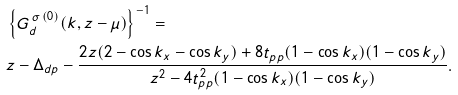Convert formula to latex. <formula><loc_0><loc_0><loc_500><loc_500>& \left \{ G _ { d } ^ { \, \sigma \, ( 0 ) } ( k , z - \mu ) \right \} ^ { - 1 } = \\ & z - \Delta _ { d p } - \frac { 2 z ( 2 - \cos k _ { x } - \cos k _ { y } ) + 8 t _ { p p } ( 1 - \cos k _ { x } ) ( 1 - \cos k _ { y } ) } { z ^ { 2 } - 4 t _ { p p } ^ { 2 } ( 1 - \cos k _ { x } ) ( 1 - \cos k _ { y } ) } .</formula> 